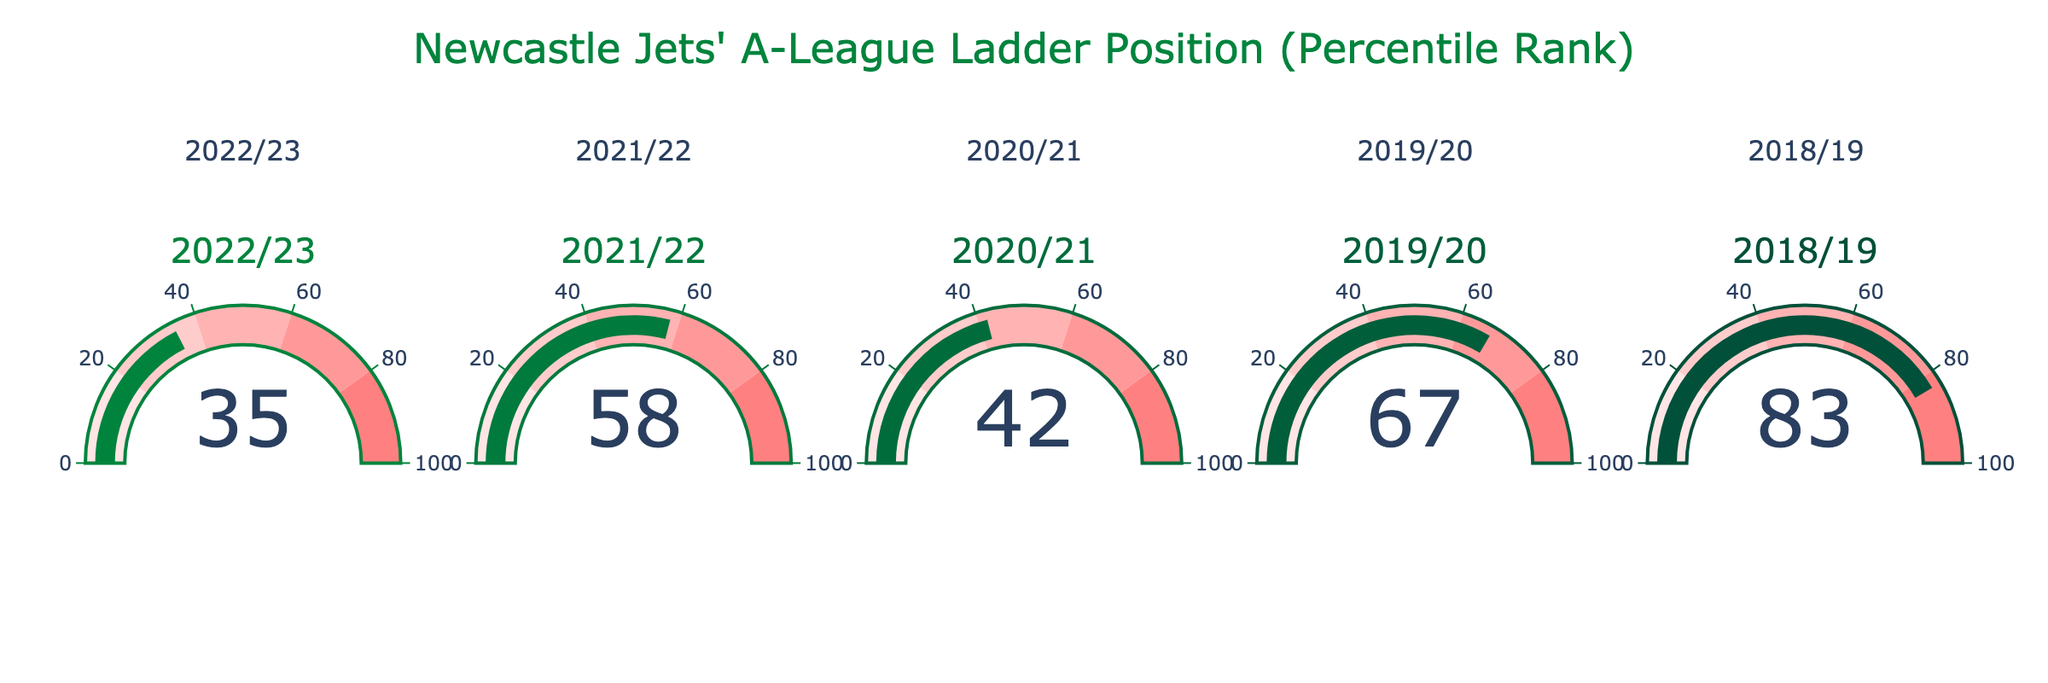What is the percentile rank for Newcastle Jets in the 2022/23 season? To answer this question, look at the gauge chart labeled "2022/23" and read the number indicated on the gauge.
Answer: 35 Which season had the highest percentile rank for Newcastle Jets? To find this, compare the values on each gauge chart. The highest value is in the season labeled "2018/19".
Answer: 2018/19 By how many percentage points did the percentile rank change from the 2022/23 season to the 2021/22 season? Subtract the percentile rank of the 2022/23 season from that of the 2021/22 season: 58 - 35 = 23.
Answer: 23 What is the average percentile rank of Newcastle Jets over these five seasons? Sum all the percentile ranks (35 + 58 + 42 + 67 + 83) and then divide by the number of seasons (5). This gives (285) / 5 = 57.
Answer: 57 Which season had a lower percentile rank, 2019/20 or 2020/21? By comparing the values on the gauges for the 2019/20 and 2020/21 seasons, we see that 2019/20 has a rank of 67 and 2020/21 has a rank of 42. Since 42 < 67, 2020/21 has the lower rank.
Answer: 2020/21 What is the difference in percentile rank between the highest and the lowest ranked seasons? Identify the highest rank (83 in 2018/19) and the lowest rank (35 in 2022/23) and subtract the lowest from the highest: 83 - 35 = 48.
Answer: 48 Between which consecutive seasons did the Newcastle Jets see the largest increase in their percentile rank? Calculate the difference in percentile ranks between consecutive seasons: 
- 2021/22 - 2022/23: 58 - 35 = 23
- 2020/21 - 2021/22: 58 - 42 = 16
- 2019/20 - 2020/21: 42 - 67 = -25
- 2018/19 - 2019/20: 67 - 83 = -16 
The largest increase is 23 between 2021/22 and 2022/23.
Answer: 2021/22 to 2022/23 Is the median percentile rank more or less than 50? Arrange the ranks in ascending order (35, 42, 58, 67, 83) and find the middle value (58). Since 58 is more than 50, the median is more than 50.
Answer: More Looking at the gauge colors, in which range does the 2021/22 season percentile rank fall? The 2021/22 season value is 58, which falls in the range of 40 to 60 on the gauge chart.
Answer: 40 to 60 